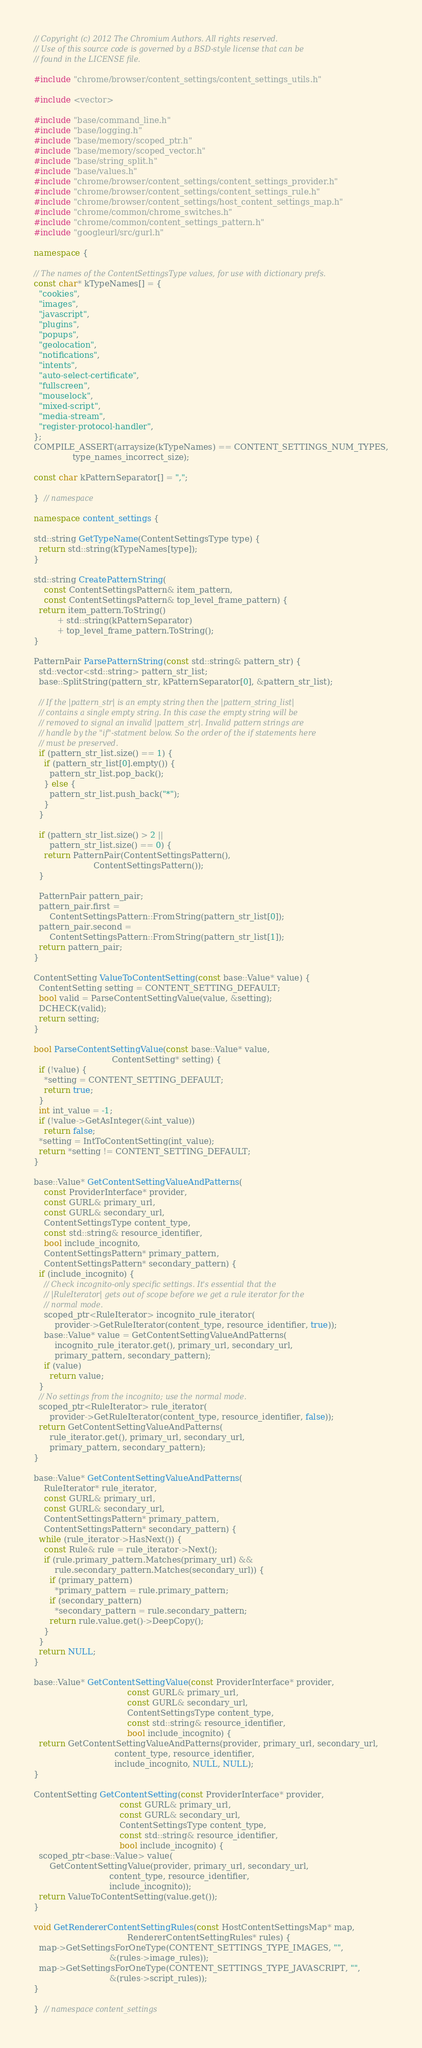<code> <loc_0><loc_0><loc_500><loc_500><_C++_>// Copyright (c) 2012 The Chromium Authors. All rights reserved.
// Use of this source code is governed by a BSD-style license that can be
// found in the LICENSE file.

#include "chrome/browser/content_settings/content_settings_utils.h"

#include <vector>

#include "base/command_line.h"
#include "base/logging.h"
#include "base/memory/scoped_ptr.h"
#include "base/memory/scoped_vector.h"
#include "base/string_split.h"
#include "base/values.h"
#include "chrome/browser/content_settings/content_settings_provider.h"
#include "chrome/browser/content_settings/content_settings_rule.h"
#include "chrome/browser/content_settings/host_content_settings_map.h"
#include "chrome/common/chrome_switches.h"
#include "chrome/common/content_settings_pattern.h"
#include "googleurl/src/gurl.h"

namespace {

// The names of the ContentSettingsType values, for use with dictionary prefs.
const char* kTypeNames[] = {
  "cookies",
  "images",
  "javascript",
  "plugins",
  "popups",
  "geolocation",
  "notifications",
  "intents",
  "auto-select-certificate",
  "fullscreen",
  "mouselock",
  "mixed-script",
  "media-stream",
  "register-protocol-handler",
};
COMPILE_ASSERT(arraysize(kTypeNames) == CONTENT_SETTINGS_NUM_TYPES,
               type_names_incorrect_size);

const char kPatternSeparator[] = ",";

}  // namespace

namespace content_settings {

std::string GetTypeName(ContentSettingsType type) {
  return std::string(kTypeNames[type]);
}

std::string CreatePatternString(
    const ContentSettingsPattern& item_pattern,
    const ContentSettingsPattern& top_level_frame_pattern) {
  return item_pattern.ToString()
         + std::string(kPatternSeparator)
         + top_level_frame_pattern.ToString();
}

PatternPair ParsePatternString(const std::string& pattern_str) {
  std::vector<std::string> pattern_str_list;
  base::SplitString(pattern_str, kPatternSeparator[0], &pattern_str_list);

  // If the |pattern_str| is an empty string then the |pattern_string_list|
  // contains a single empty string. In this case the empty string will be
  // removed to signal an invalid |pattern_str|. Invalid pattern strings are
  // handle by the "if"-statment below. So the order of the if statements here
  // must be preserved.
  if (pattern_str_list.size() == 1) {
    if (pattern_str_list[0].empty()) {
      pattern_str_list.pop_back();
    } else {
      pattern_str_list.push_back("*");
    }
  }

  if (pattern_str_list.size() > 2 ||
      pattern_str_list.size() == 0) {
    return PatternPair(ContentSettingsPattern(),
                       ContentSettingsPattern());
  }

  PatternPair pattern_pair;
  pattern_pair.first =
      ContentSettingsPattern::FromString(pattern_str_list[0]);
  pattern_pair.second =
      ContentSettingsPattern::FromString(pattern_str_list[1]);
  return pattern_pair;
}

ContentSetting ValueToContentSetting(const base::Value* value) {
  ContentSetting setting = CONTENT_SETTING_DEFAULT;
  bool valid = ParseContentSettingValue(value, &setting);
  DCHECK(valid);
  return setting;
}

bool ParseContentSettingValue(const base::Value* value,
                              ContentSetting* setting) {
  if (!value) {
    *setting = CONTENT_SETTING_DEFAULT;
    return true;
  }
  int int_value = -1;
  if (!value->GetAsInteger(&int_value))
    return false;
  *setting = IntToContentSetting(int_value);
  return *setting != CONTENT_SETTING_DEFAULT;
}

base::Value* GetContentSettingValueAndPatterns(
    const ProviderInterface* provider,
    const GURL& primary_url,
    const GURL& secondary_url,
    ContentSettingsType content_type,
    const std::string& resource_identifier,
    bool include_incognito,
    ContentSettingsPattern* primary_pattern,
    ContentSettingsPattern* secondary_pattern) {
  if (include_incognito) {
    // Check incognito-only specific settings. It's essential that the
    // |RuleIterator| gets out of scope before we get a rule iterator for the
    // normal mode.
    scoped_ptr<RuleIterator> incognito_rule_iterator(
        provider->GetRuleIterator(content_type, resource_identifier, true));
    base::Value* value = GetContentSettingValueAndPatterns(
        incognito_rule_iterator.get(), primary_url, secondary_url,
        primary_pattern, secondary_pattern);
    if (value)
      return value;
  }
  // No settings from the incognito; use the normal mode.
  scoped_ptr<RuleIterator> rule_iterator(
      provider->GetRuleIterator(content_type, resource_identifier, false));
  return GetContentSettingValueAndPatterns(
      rule_iterator.get(), primary_url, secondary_url,
      primary_pattern, secondary_pattern);
}

base::Value* GetContentSettingValueAndPatterns(
    RuleIterator* rule_iterator,
    const GURL& primary_url,
    const GURL& secondary_url,
    ContentSettingsPattern* primary_pattern,
    ContentSettingsPattern* secondary_pattern) {
  while (rule_iterator->HasNext()) {
    const Rule& rule = rule_iterator->Next();
    if (rule.primary_pattern.Matches(primary_url) &&
        rule.secondary_pattern.Matches(secondary_url)) {
      if (primary_pattern)
        *primary_pattern = rule.primary_pattern;
      if (secondary_pattern)
        *secondary_pattern = rule.secondary_pattern;
      return rule.value.get()->DeepCopy();
    }
  }
  return NULL;
}

base::Value* GetContentSettingValue(const ProviderInterface* provider,
                                    const GURL& primary_url,
                                    const GURL& secondary_url,
                                    ContentSettingsType content_type,
                                    const std::string& resource_identifier,
                                    bool include_incognito) {
  return GetContentSettingValueAndPatterns(provider, primary_url, secondary_url,
                               content_type, resource_identifier,
                               include_incognito, NULL, NULL);
}

ContentSetting GetContentSetting(const ProviderInterface* provider,
                                 const GURL& primary_url,
                                 const GURL& secondary_url,
                                 ContentSettingsType content_type,
                                 const std::string& resource_identifier,
                                 bool include_incognito) {
  scoped_ptr<base::Value> value(
      GetContentSettingValue(provider, primary_url, secondary_url,
                             content_type, resource_identifier,
                             include_incognito));
  return ValueToContentSetting(value.get());
}

void GetRendererContentSettingRules(const HostContentSettingsMap* map,
                                    RendererContentSettingRules* rules) {
  map->GetSettingsForOneType(CONTENT_SETTINGS_TYPE_IMAGES, "",
                             &(rules->image_rules));
  map->GetSettingsForOneType(CONTENT_SETTINGS_TYPE_JAVASCRIPT, "",
                             &(rules->script_rules));
}

}  // namespace content_settings
</code> 